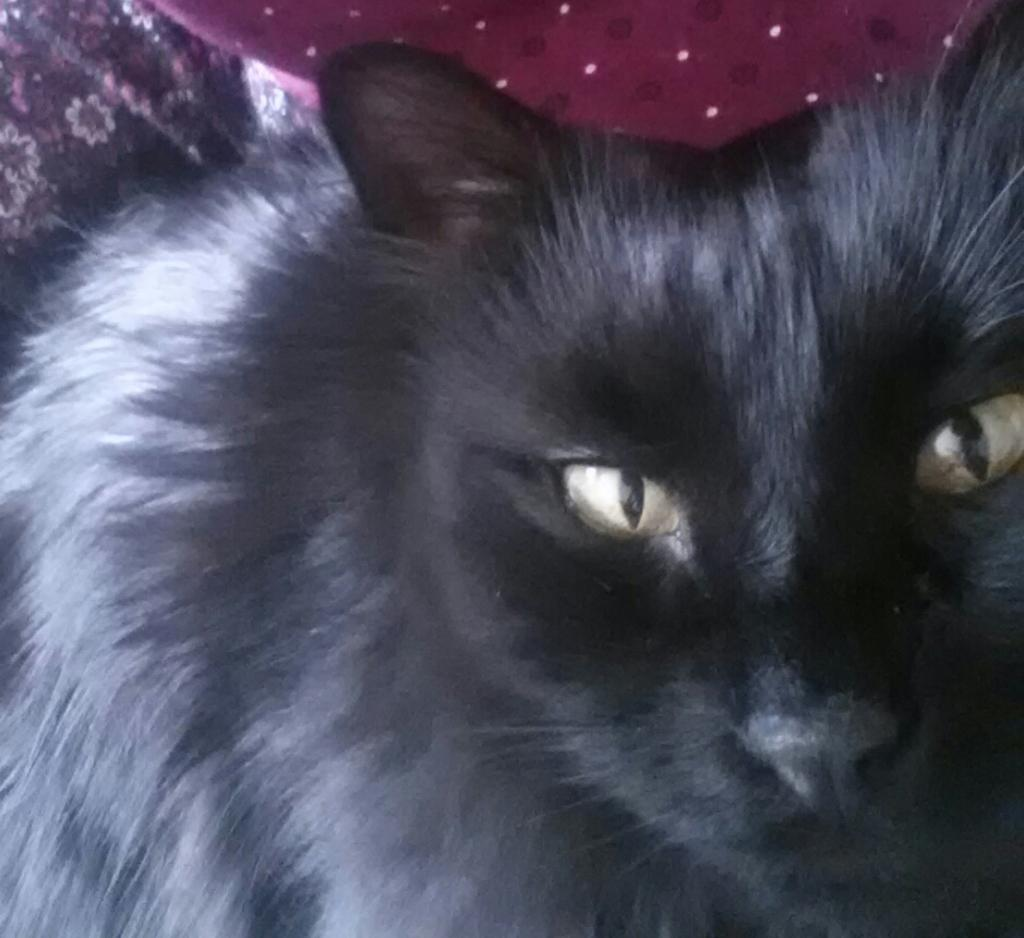What type of animal is in the image? There is a cat in the image. What color is the cat? The cat is black in color. Are there any objects in the image that have a specific color? Yes, there are objects in the image that are red in color. What type of tree is growing in the image? There is no tree present in the image. What flavor of cake can be seen in the image? There is no cake present in the image. 